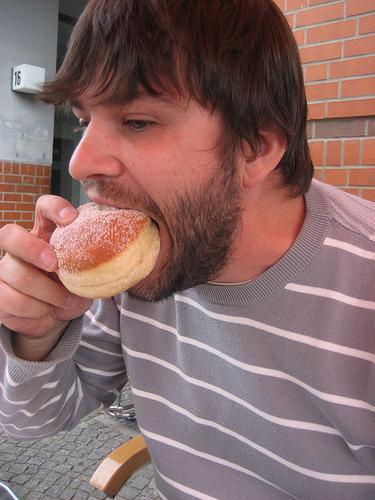How many donuts the man is eating?
Give a very brief answer. 1. 